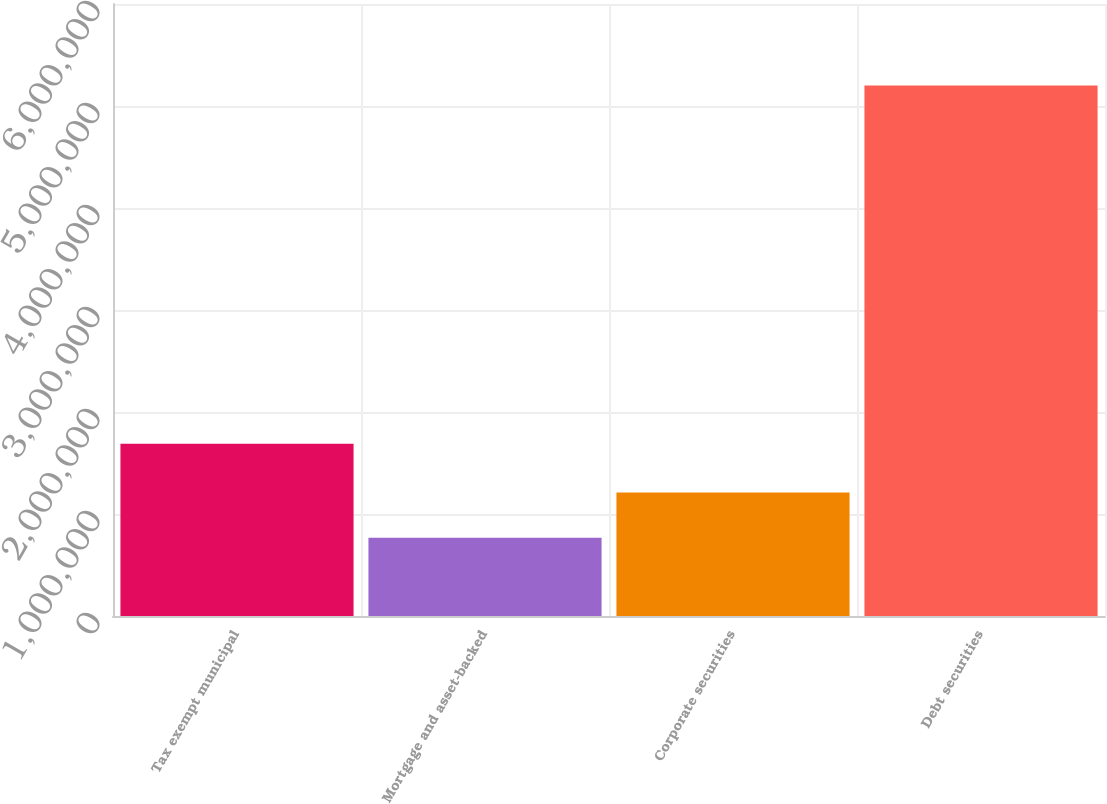<chart> <loc_0><loc_0><loc_500><loc_500><bar_chart><fcel>Tax exempt municipal<fcel>Mortgage and asset-backed<fcel>Corporate securities<fcel>Debt securities<nl><fcel>1.68946e+06<fcel>766202<fcel>1.2096e+06<fcel>5.20014e+06<nl></chart> 